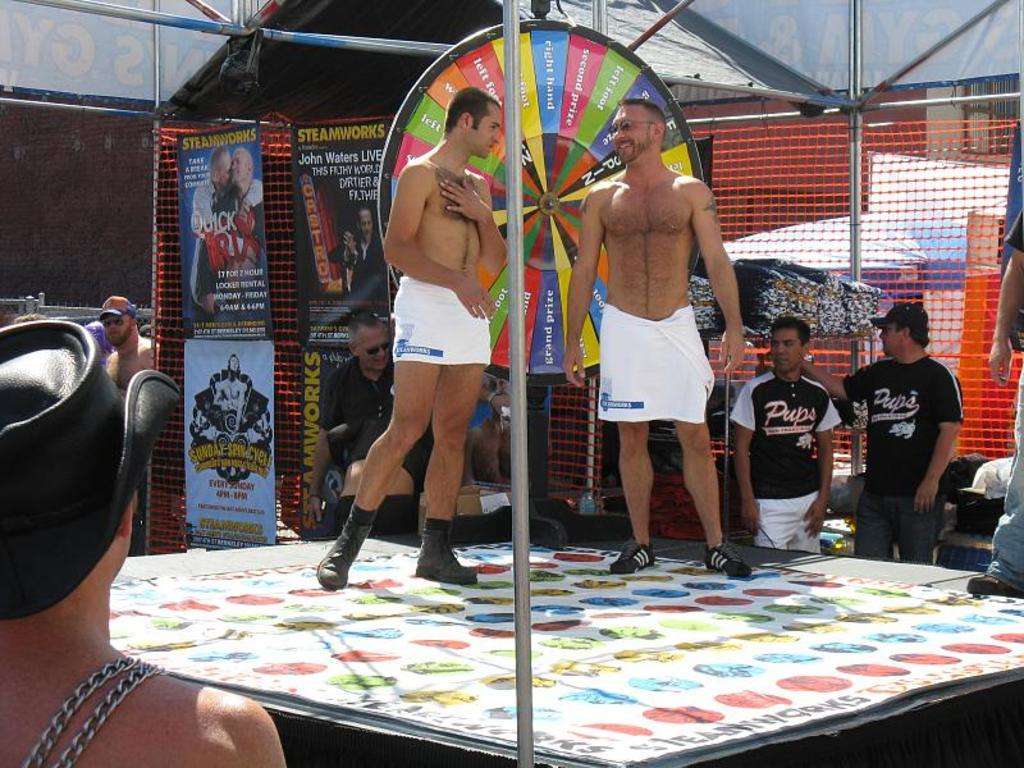<image>
Relay a brief, clear account of the picture shown. The men are promoting John Waters Live by Steamworks. 